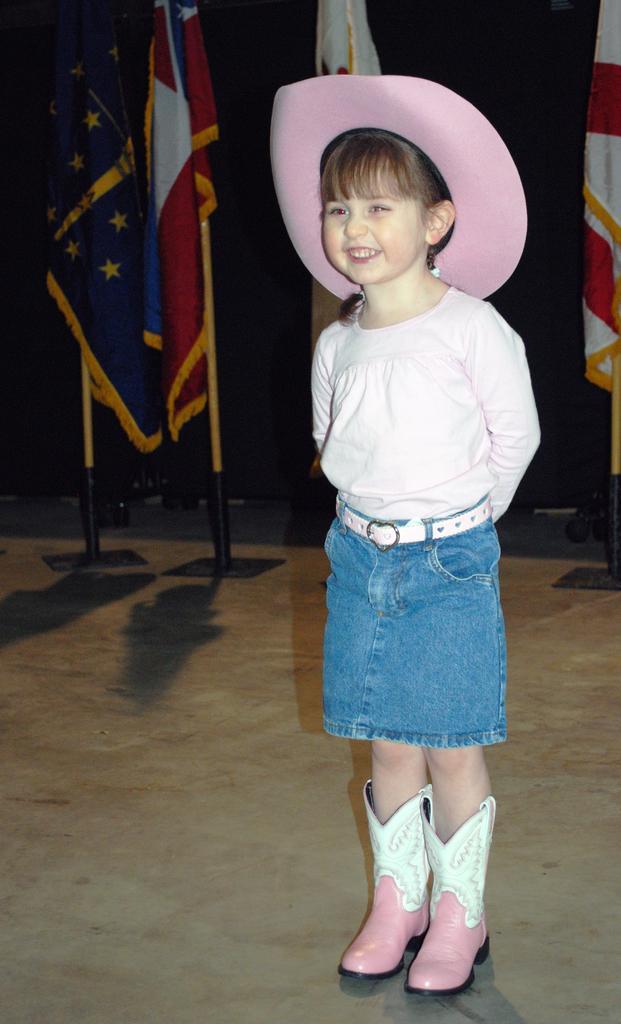Could you give a brief overview of what you see in this image? There is one kid standing and wearing a white color dress on the right side of this image. We can see flags in the background. 